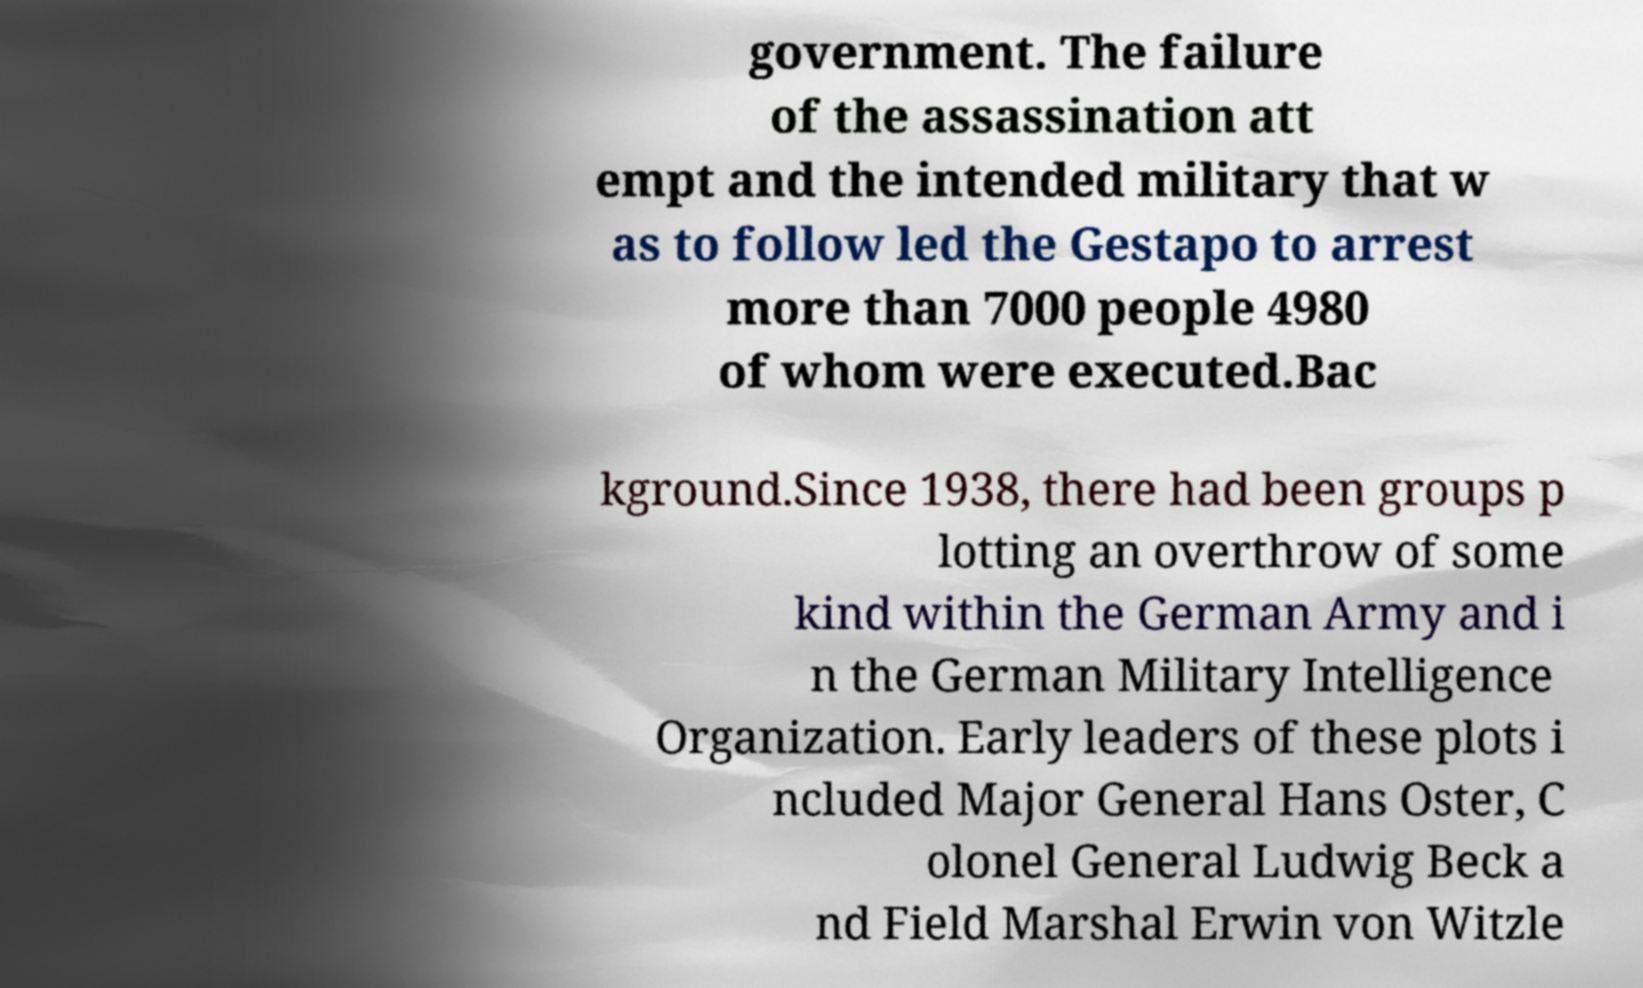Could you assist in decoding the text presented in this image and type it out clearly? government. The failure of the assassination att empt and the intended military that w as to follow led the Gestapo to arrest more than 7000 people 4980 of whom were executed.Bac kground.Since 1938, there had been groups p lotting an overthrow of some kind within the German Army and i n the German Military Intelligence Organization. Early leaders of these plots i ncluded Major General Hans Oster, C olonel General Ludwig Beck a nd Field Marshal Erwin von Witzle 